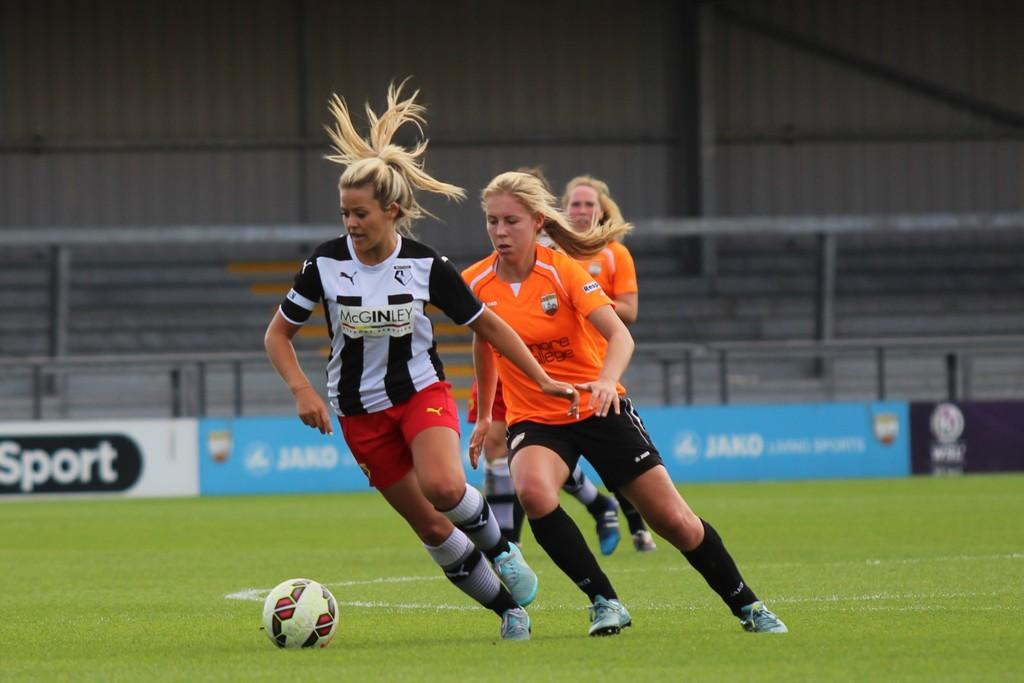How many people are in the image? There are three women in the image. What activity are the women engaged in? The women are playing football. What can be seen in the background of the image? There is a board and a railing in the background of the image. What type of plastic material is used to design the prison in the image? There is no prison present in the image, and therefore no plastic material used for its design. 